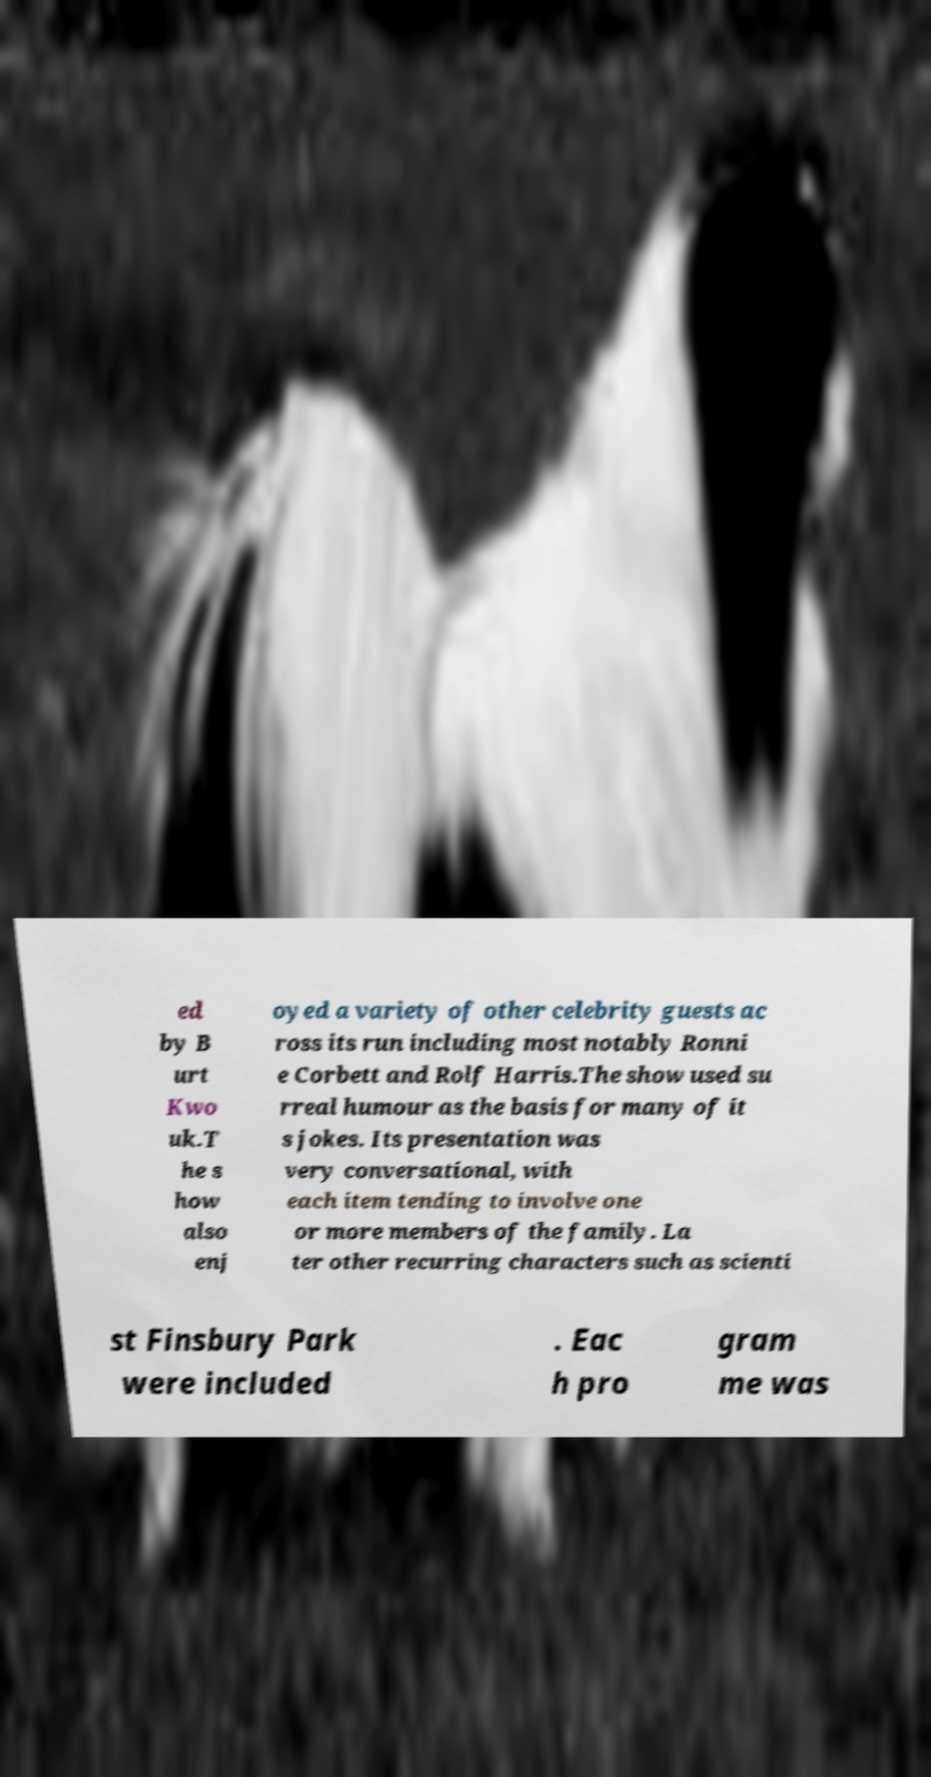Can you read and provide the text displayed in the image?This photo seems to have some interesting text. Can you extract and type it out for me? ed by B urt Kwo uk.T he s how also enj oyed a variety of other celebrity guests ac ross its run including most notably Ronni e Corbett and Rolf Harris.The show used su rreal humour as the basis for many of it s jokes. Its presentation was very conversational, with each item tending to involve one or more members of the family. La ter other recurring characters such as scienti st Finsbury Park were included . Eac h pro gram me was 